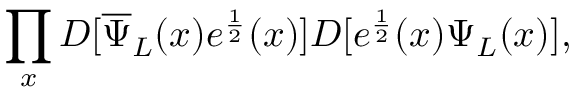<formula> <loc_0><loc_0><loc_500><loc_500>\prod _ { x } D [ { \overline { \Psi } } _ { L } ( x ) e ^ { \frac { 1 } { 2 } } ( x ) ] D [ e ^ { \frac { 1 } { 2 } } ( x ) \Psi _ { L } ( x ) ] ,</formula> 